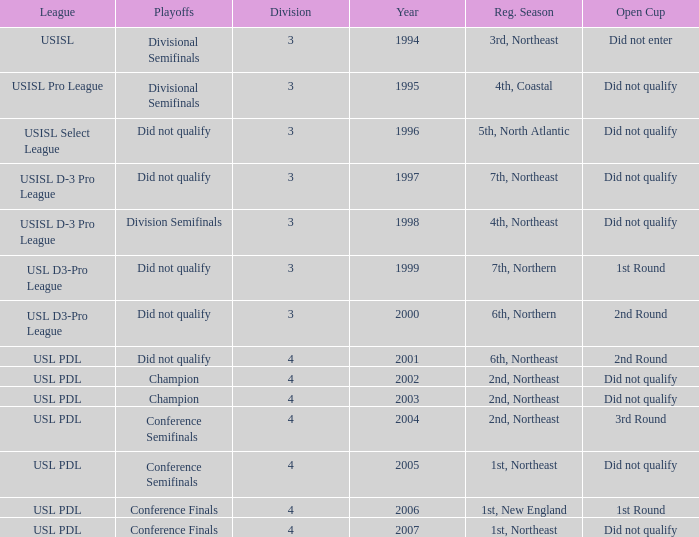Name the league for 2003 USL PDL. 